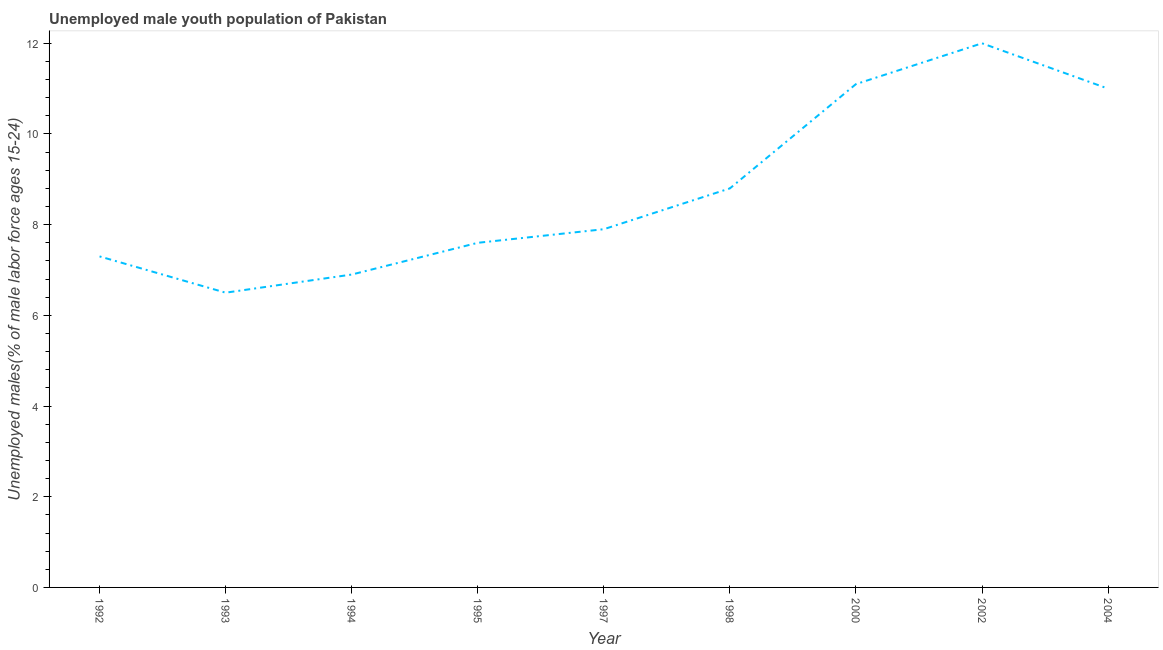What is the unemployed male youth in 1994?
Your answer should be compact. 6.9. Across all years, what is the minimum unemployed male youth?
Your response must be concise. 6.5. In which year was the unemployed male youth minimum?
Your answer should be very brief. 1993. What is the sum of the unemployed male youth?
Your answer should be compact. 79.1. What is the difference between the unemployed male youth in 1992 and 1998?
Provide a succinct answer. -1.5. What is the average unemployed male youth per year?
Your response must be concise. 8.79. What is the median unemployed male youth?
Offer a very short reply. 7.9. Do a majority of the years between 1995 and 2000 (inclusive) have unemployed male youth greater than 6.4 %?
Provide a succinct answer. Yes. What is the ratio of the unemployed male youth in 1993 to that in 1997?
Provide a succinct answer. 0.82. Is the unemployed male youth in 1995 less than that in 1997?
Offer a very short reply. Yes. Is the difference between the unemployed male youth in 1993 and 2004 greater than the difference between any two years?
Ensure brevity in your answer.  No. What is the difference between the highest and the second highest unemployed male youth?
Your response must be concise. 0.9. Is the sum of the unemployed male youth in 1997 and 1998 greater than the maximum unemployed male youth across all years?
Offer a terse response. Yes. What is the difference between the highest and the lowest unemployed male youth?
Provide a short and direct response. 5.5. In how many years, is the unemployed male youth greater than the average unemployed male youth taken over all years?
Keep it short and to the point. 4. Does the unemployed male youth monotonically increase over the years?
Give a very brief answer. No. What is the title of the graph?
Offer a terse response. Unemployed male youth population of Pakistan. What is the label or title of the X-axis?
Provide a succinct answer. Year. What is the label or title of the Y-axis?
Keep it short and to the point. Unemployed males(% of male labor force ages 15-24). What is the Unemployed males(% of male labor force ages 15-24) in 1992?
Ensure brevity in your answer.  7.3. What is the Unemployed males(% of male labor force ages 15-24) in 1994?
Your response must be concise. 6.9. What is the Unemployed males(% of male labor force ages 15-24) in 1995?
Keep it short and to the point. 7.6. What is the Unemployed males(% of male labor force ages 15-24) in 1997?
Your answer should be compact. 7.9. What is the Unemployed males(% of male labor force ages 15-24) in 1998?
Offer a terse response. 8.8. What is the Unemployed males(% of male labor force ages 15-24) in 2000?
Your answer should be very brief. 11.1. What is the difference between the Unemployed males(% of male labor force ages 15-24) in 1992 and 1995?
Provide a short and direct response. -0.3. What is the difference between the Unemployed males(% of male labor force ages 15-24) in 1992 and 2000?
Your answer should be compact. -3.8. What is the difference between the Unemployed males(% of male labor force ages 15-24) in 1992 and 2002?
Give a very brief answer. -4.7. What is the difference between the Unemployed males(% of male labor force ages 15-24) in 1993 and 1994?
Offer a terse response. -0.4. What is the difference between the Unemployed males(% of male labor force ages 15-24) in 1993 and 1995?
Your answer should be very brief. -1.1. What is the difference between the Unemployed males(% of male labor force ages 15-24) in 1993 and 1998?
Offer a terse response. -2.3. What is the difference between the Unemployed males(% of male labor force ages 15-24) in 1993 and 2000?
Ensure brevity in your answer.  -4.6. What is the difference between the Unemployed males(% of male labor force ages 15-24) in 1993 and 2002?
Offer a very short reply. -5.5. What is the difference between the Unemployed males(% of male labor force ages 15-24) in 1994 and 1997?
Give a very brief answer. -1. What is the difference between the Unemployed males(% of male labor force ages 15-24) in 1994 and 2000?
Your response must be concise. -4.2. What is the difference between the Unemployed males(% of male labor force ages 15-24) in 1994 and 2002?
Your answer should be compact. -5.1. What is the difference between the Unemployed males(% of male labor force ages 15-24) in 1994 and 2004?
Your answer should be compact. -4.1. What is the difference between the Unemployed males(% of male labor force ages 15-24) in 1995 and 1997?
Your response must be concise. -0.3. What is the difference between the Unemployed males(% of male labor force ages 15-24) in 1995 and 2002?
Make the answer very short. -4.4. What is the difference between the Unemployed males(% of male labor force ages 15-24) in 1997 and 2000?
Offer a terse response. -3.2. What is the difference between the Unemployed males(% of male labor force ages 15-24) in 1997 and 2002?
Offer a terse response. -4.1. What is the difference between the Unemployed males(% of male labor force ages 15-24) in 1997 and 2004?
Keep it short and to the point. -3.1. What is the difference between the Unemployed males(% of male labor force ages 15-24) in 2000 and 2002?
Make the answer very short. -0.9. What is the difference between the Unemployed males(% of male labor force ages 15-24) in 2000 and 2004?
Offer a very short reply. 0.1. What is the difference between the Unemployed males(% of male labor force ages 15-24) in 2002 and 2004?
Give a very brief answer. 1. What is the ratio of the Unemployed males(% of male labor force ages 15-24) in 1992 to that in 1993?
Ensure brevity in your answer.  1.12. What is the ratio of the Unemployed males(% of male labor force ages 15-24) in 1992 to that in 1994?
Give a very brief answer. 1.06. What is the ratio of the Unemployed males(% of male labor force ages 15-24) in 1992 to that in 1995?
Ensure brevity in your answer.  0.96. What is the ratio of the Unemployed males(% of male labor force ages 15-24) in 1992 to that in 1997?
Make the answer very short. 0.92. What is the ratio of the Unemployed males(% of male labor force ages 15-24) in 1992 to that in 1998?
Keep it short and to the point. 0.83. What is the ratio of the Unemployed males(% of male labor force ages 15-24) in 1992 to that in 2000?
Provide a short and direct response. 0.66. What is the ratio of the Unemployed males(% of male labor force ages 15-24) in 1992 to that in 2002?
Your answer should be compact. 0.61. What is the ratio of the Unemployed males(% of male labor force ages 15-24) in 1992 to that in 2004?
Offer a very short reply. 0.66. What is the ratio of the Unemployed males(% of male labor force ages 15-24) in 1993 to that in 1994?
Give a very brief answer. 0.94. What is the ratio of the Unemployed males(% of male labor force ages 15-24) in 1993 to that in 1995?
Ensure brevity in your answer.  0.85. What is the ratio of the Unemployed males(% of male labor force ages 15-24) in 1993 to that in 1997?
Your answer should be compact. 0.82. What is the ratio of the Unemployed males(% of male labor force ages 15-24) in 1993 to that in 1998?
Give a very brief answer. 0.74. What is the ratio of the Unemployed males(% of male labor force ages 15-24) in 1993 to that in 2000?
Provide a succinct answer. 0.59. What is the ratio of the Unemployed males(% of male labor force ages 15-24) in 1993 to that in 2002?
Ensure brevity in your answer.  0.54. What is the ratio of the Unemployed males(% of male labor force ages 15-24) in 1993 to that in 2004?
Provide a short and direct response. 0.59. What is the ratio of the Unemployed males(% of male labor force ages 15-24) in 1994 to that in 1995?
Provide a short and direct response. 0.91. What is the ratio of the Unemployed males(% of male labor force ages 15-24) in 1994 to that in 1997?
Your response must be concise. 0.87. What is the ratio of the Unemployed males(% of male labor force ages 15-24) in 1994 to that in 1998?
Offer a very short reply. 0.78. What is the ratio of the Unemployed males(% of male labor force ages 15-24) in 1994 to that in 2000?
Ensure brevity in your answer.  0.62. What is the ratio of the Unemployed males(% of male labor force ages 15-24) in 1994 to that in 2002?
Provide a succinct answer. 0.57. What is the ratio of the Unemployed males(% of male labor force ages 15-24) in 1994 to that in 2004?
Provide a succinct answer. 0.63. What is the ratio of the Unemployed males(% of male labor force ages 15-24) in 1995 to that in 1998?
Make the answer very short. 0.86. What is the ratio of the Unemployed males(% of male labor force ages 15-24) in 1995 to that in 2000?
Your answer should be compact. 0.69. What is the ratio of the Unemployed males(% of male labor force ages 15-24) in 1995 to that in 2002?
Provide a short and direct response. 0.63. What is the ratio of the Unemployed males(% of male labor force ages 15-24) in 1995 to that in 2004?
Give a very brief answer. 0.69. What is the ratio of the Unemployed males(% of male labor force ages 15-24) in 1997 to that in 1998?
Make the answer very short. 0.9. What is the ratio of the Unemployed males(% of male labor force ages 15-24) in 1997 to that in 2000?
Provide a succinct answer. 0.71. What is the ratio of the Unemployed males(% of male labor force ages 15-24) in 1997 to that in 2002?
Your answer should be very brief. 0.66. What is the ratio of the Unemployed males(% of male labor force ages 15-24) in 1997 to that in 2004?
Give a very brief answer. 0.72. What is the ratio of the Unemployed males(% of male labor force ages 15-24) in 1998 to that in 2000?
Offer a terse response. 0.79. What is the ratio of the Unemployed males(% of male labor force ages 15-24) in 1998 to that in 2002?
Offer a very short reply. 0.73. What is the ratio of the Unemployed males(% of male labor force ages 15-24) in 1998 to that in 2004?
Keep it short and to the point. 0.8. What is the ratio of the Unemployed males(% of male labor force ages 15-24) in 2000 to that in 2002?
Give a very brief answer. 0.93. What is the ratio of the Unemployed males(% of male labor force ages 15-24) in 2002 to that in 2004?
Make the answer very short. 1.09. 